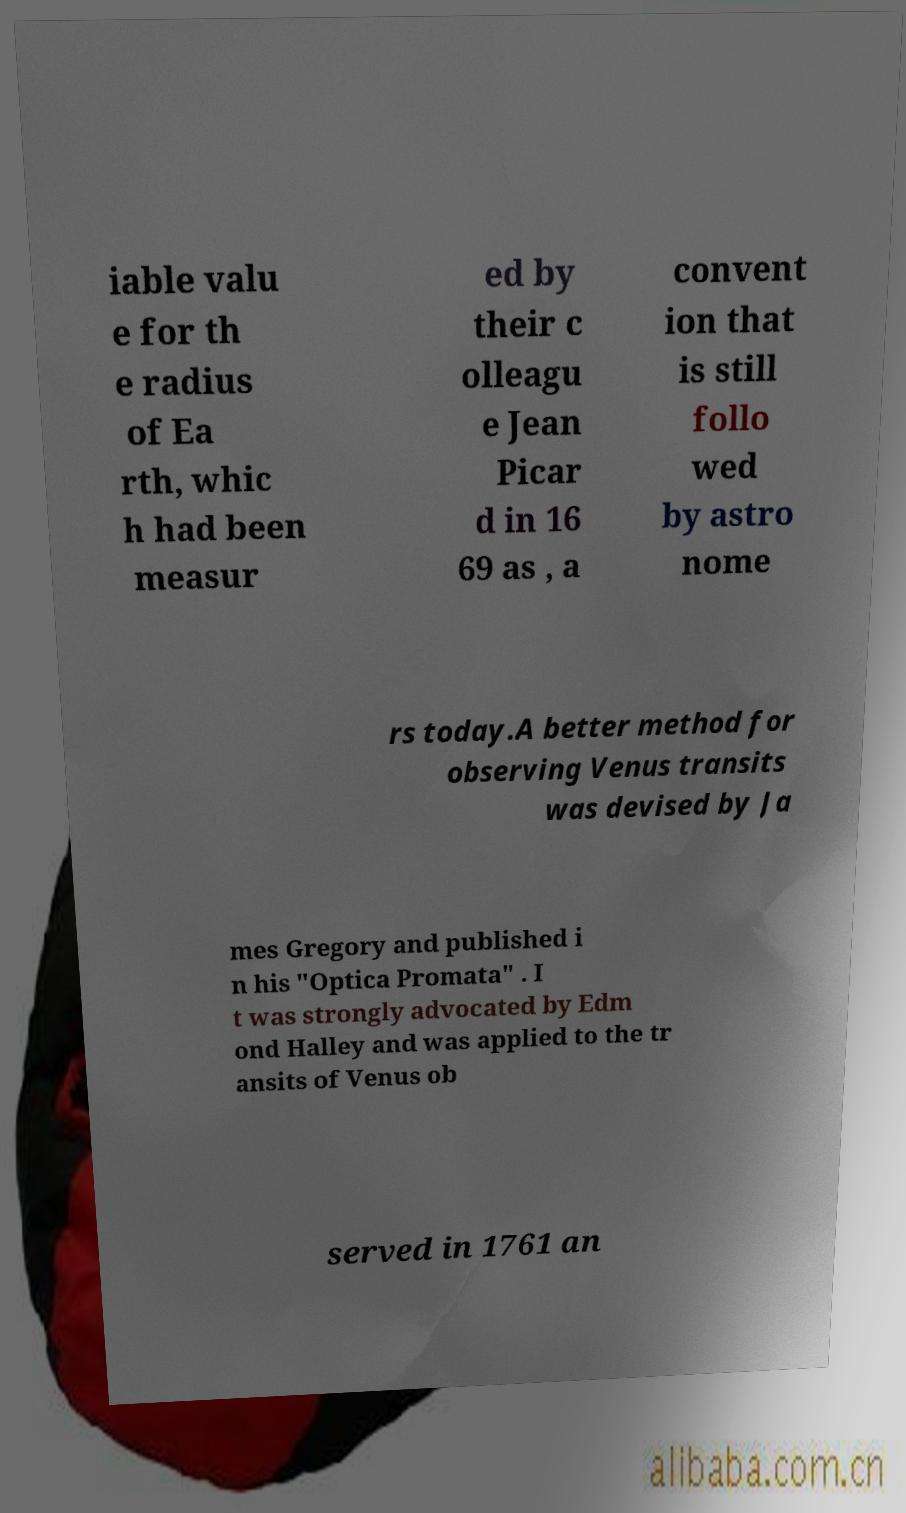Can you accurately transcribe the text from the provided image for me? iable valu e for th e radius of Ea rth, whic h had been measur ed by their c olleagu e Jean Picar d in 16 69 as , a convent ion that is still follo wed by astro nome rs today.A better method for observing Venus transits was devised by Ja mes Gregory and published i n his "Optica Promata" . I t was strongly advocated by Edm ond Halley and was applied to the tr ansits of Venus ob served in 1761 an 